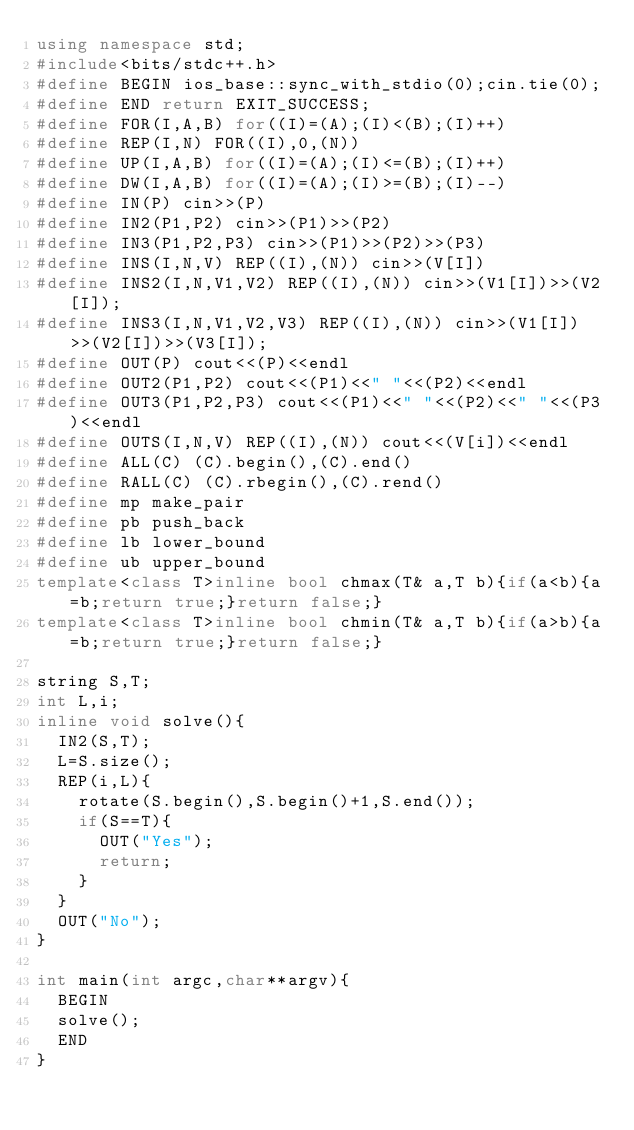Convert code to text. <code><loc_0><loc_0><loc_500><loc_500><_C++_>using namespace std;
#include<bits/stdc++.h>
#define BEGIN ios_base::sync_with_stdio(0);cin.tie(0);
#define END return EXIT_SUCCESS;
#define FOR(I,A,B) for((I)=(A);(I)<(B);(I)++)
#define REP(I,N) FOR((I),0,(N))
#define UP(I,A,B) for((I)=(A);(I)<=(B);(I)++)
#define DW(I,A,B) for((I)=(A);(I)>=(B);(I)--)
#define IN(P) cin>>(P)
#define IN2(P1,P2) cin>>(P1)>>(P2)
#define IN3(P1,P2,P3) cin>>(P1)>>(P2)>>(P3)
#define INS(I,N,V) REP((I),(N)) cin>>(V[I])
#define INS2(I,N,V1,V2) REP((I),(N)) cin>>(V1[I])>>(V2[I]);
#define INS3(I,N,V1,V2,V3) REP((I),(N)) cin>>(V1[I])>>(V2[I])>>(V3[I]);
#define OUT(P) cout<<(P)<<endl
#define OUT2(P1,P2) cout<<(P1)<<" "<<(P2)<<endl
#define OUT3(P1,P2,P3) cout<<(P1)<<" "<<(P2)<<" "<<(P3)<<endl
#define OUTS(I,N,V) REP((I),(N)) cout<<(V[i])<<endl
#define ALL(C) (C).begin(),(C).end()
#define RALL(C) (C).rbegin(),(C).rend()
#define mp make_pair
#define pb push_back
#define lb lower_bound
#define ub upper_bound
template<class T>inline bool chmax(T& a,T b){if(a<b){a=b;return true;}return false;}
template<class T>inline bool chmin(T& a,T b){if(a>b){a=b;return true;}return false;}

string S,T;
int L,i;
inline void solve(){
  IN2(S,T);
  L=S.size();
  REP(i,L){
    rotate(S.begin(),S.begin()+1,S.end());
    if(S==T){
      OUT("Yes");
      return;
    }
  }
  OUT("No");
}

int main(int argc,char**argv){
  BEGIN
  solve();
  END
}
</code> 